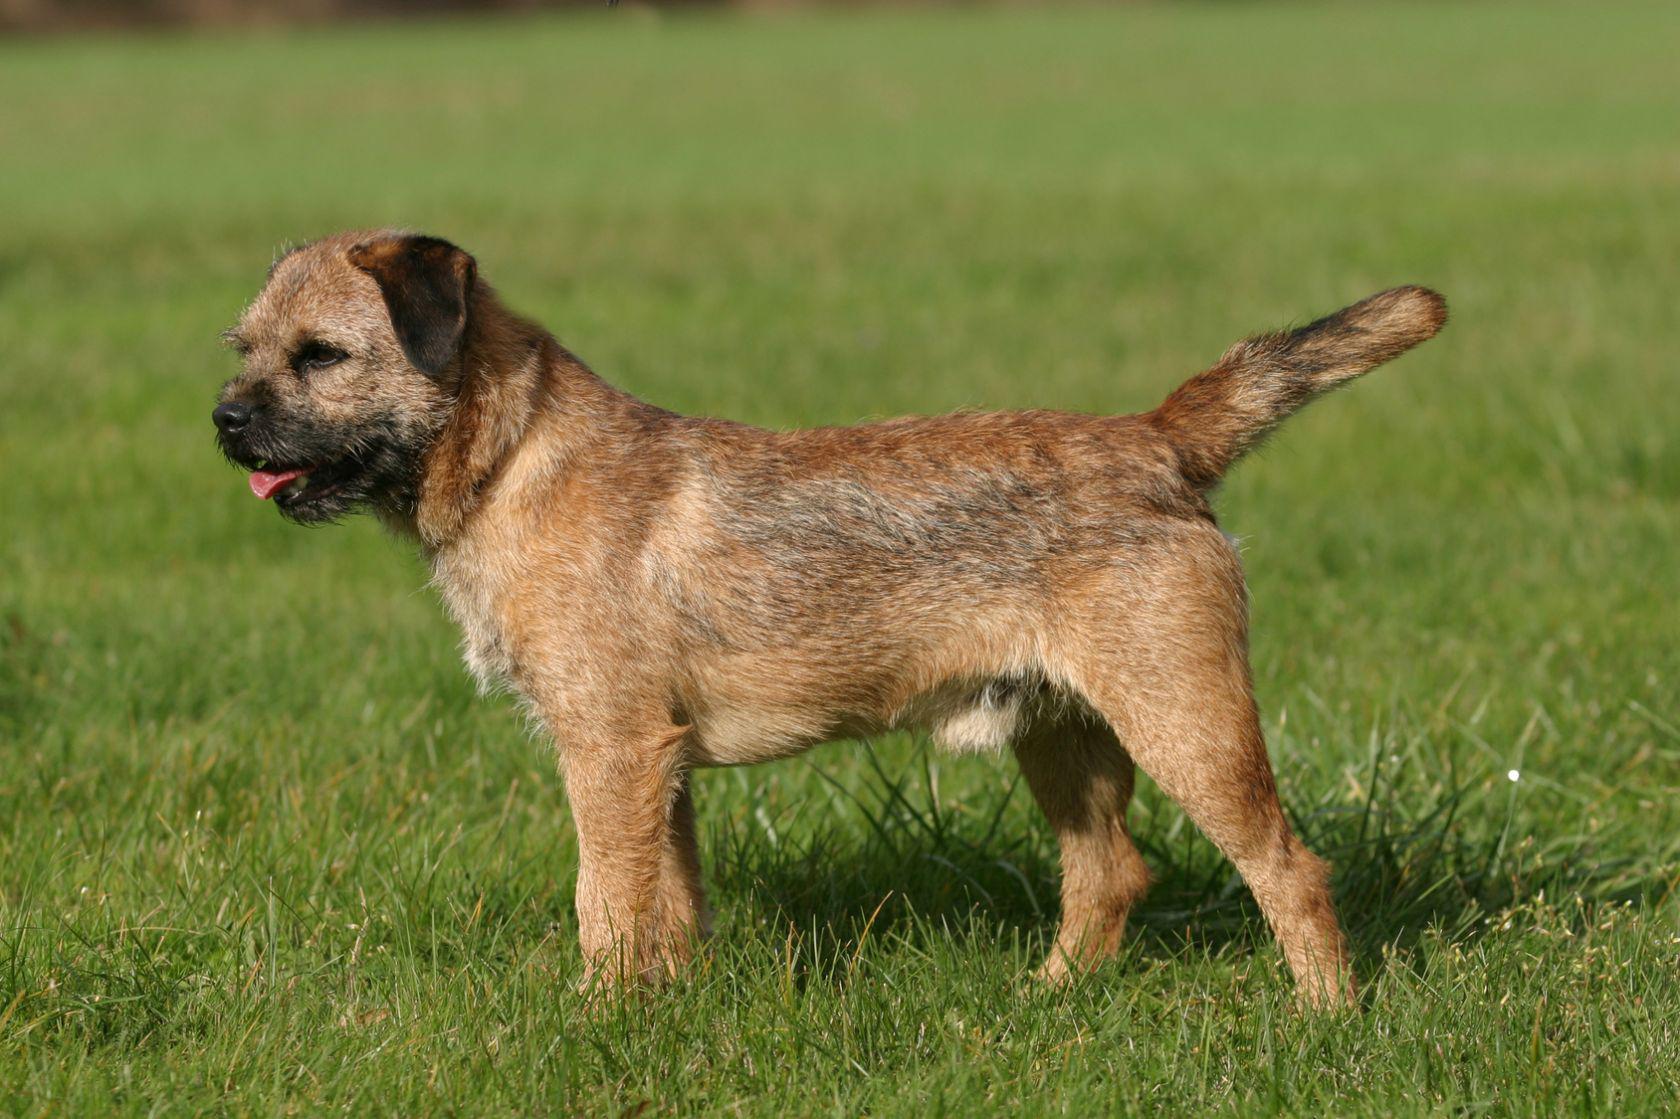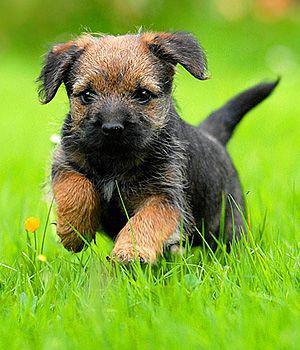The first image is the image on the left, the second image is the image on the right. For the images displayed, is the sentence "One of the dogs is wearing something colorful around its neck area." factually correct? Answer yes or no. No. 